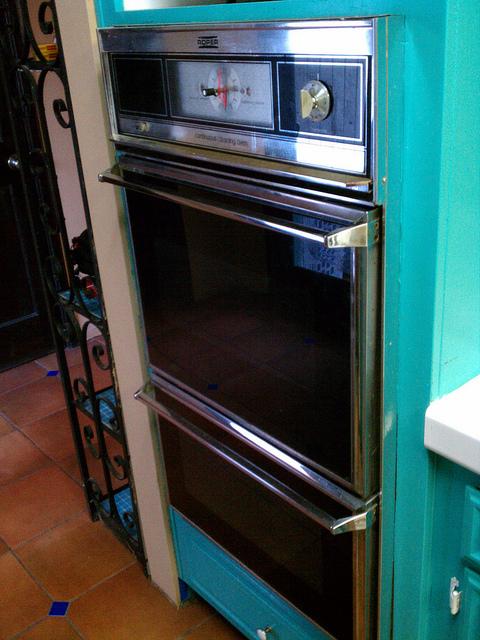What room is this in?
Give a very brief answer. Kitchen. Where is a small square tile?
Answer briefly. Floor. Is this stove a model from the last five years?
Concise answer only. No. 